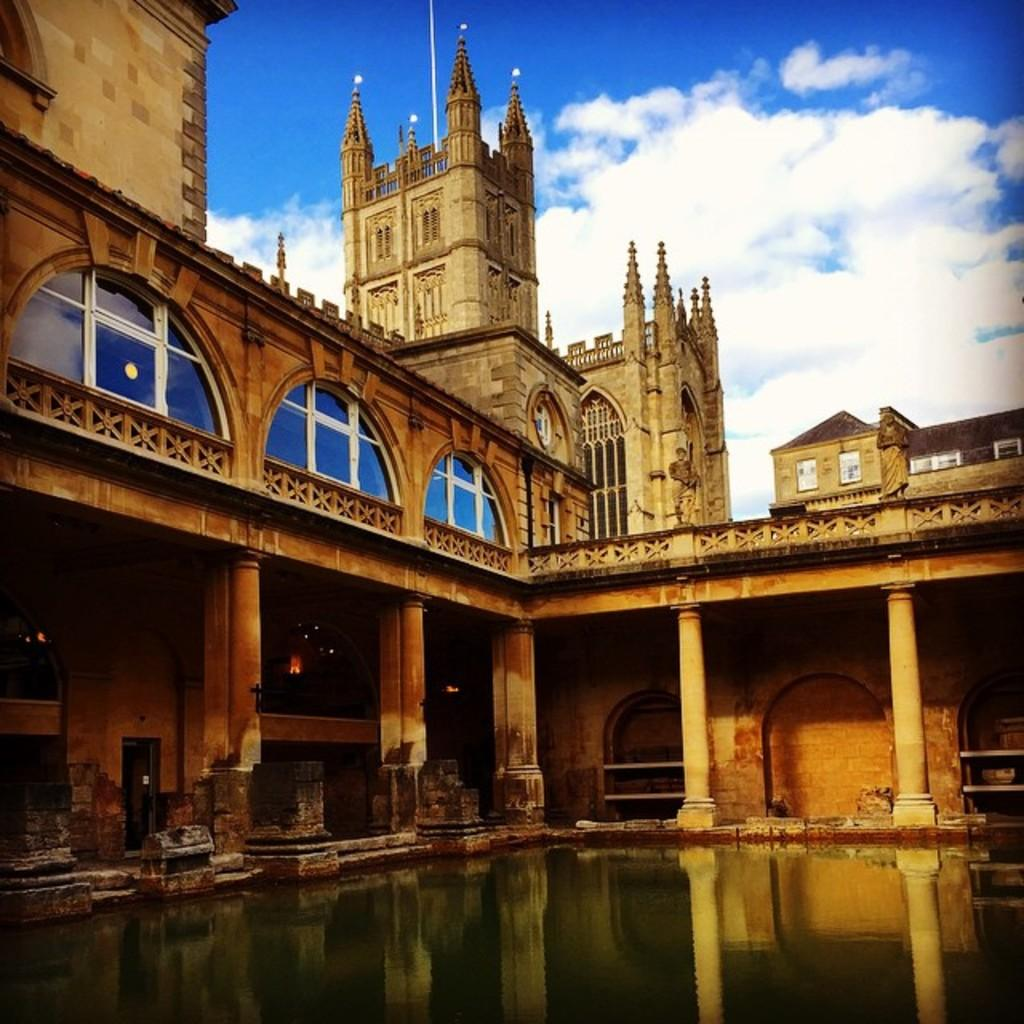What type of structure is present in the image? There is a building in the image. What architectural feature can be seen on the building? The building has pillars. What natural element is present at the bottom of the image? There is a water pond at the bottom of the image. What is visible at the top of the image? The sky is visible at the top of the image. Where is the doctor located in the image? There is no doctor present in the image. What type of sand can be seen on the ground in the image? There is no sand present in the image; it features a building, a water pond, and the sky. 